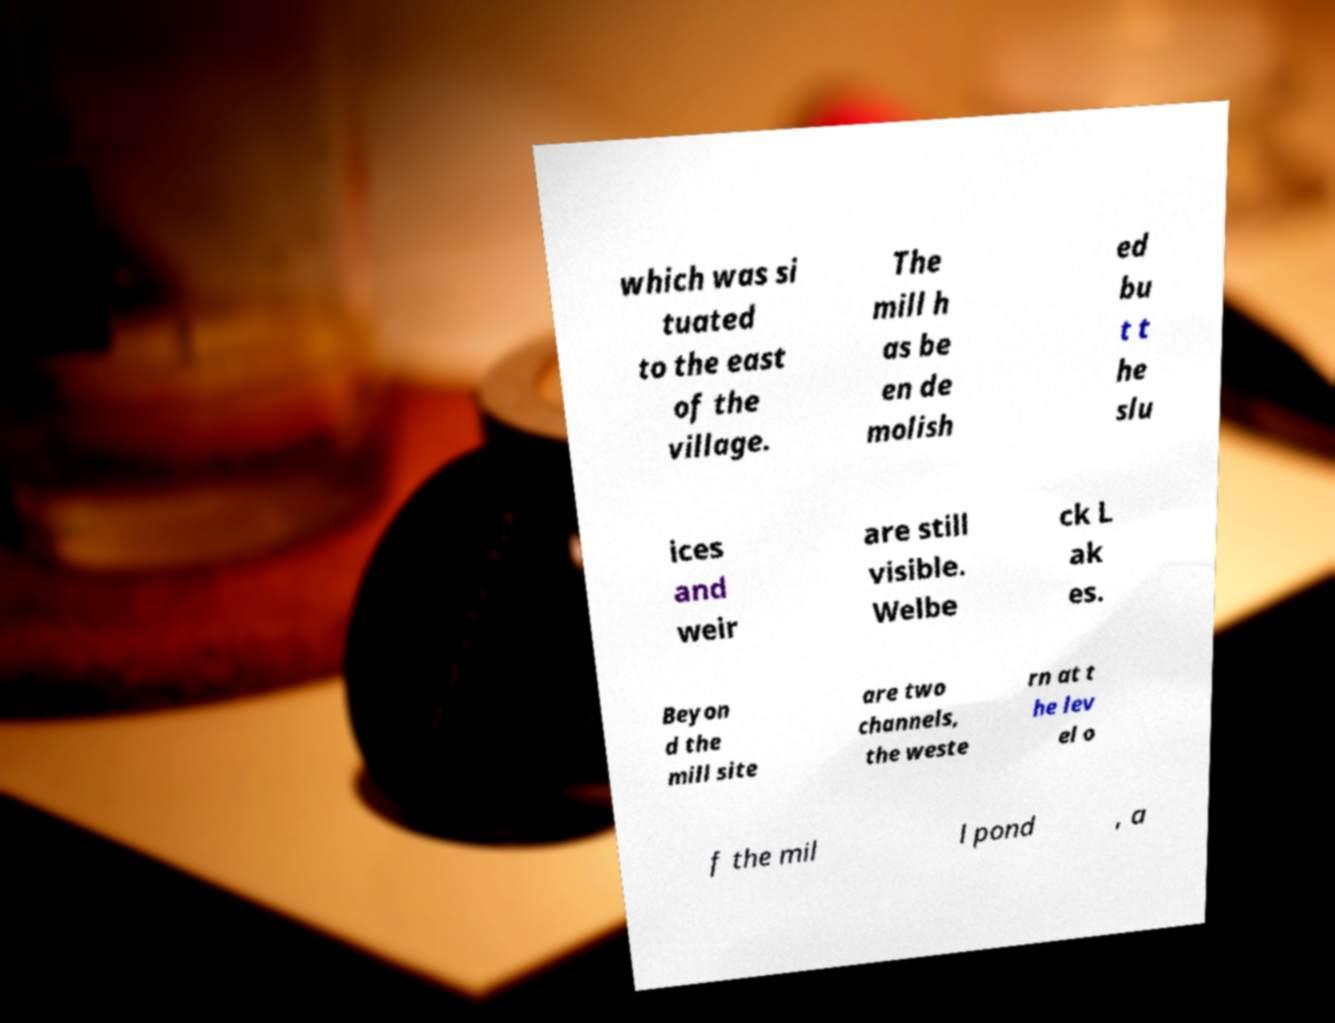Can you read and provide the text displayed in the image?This photo seems to have some interesting text. Can you extract and type it out for me? which was si tuated to the east of the village. The mill h as be en de molish ed bu t t he slu ices and weir are still visible. Welbe ck L ak es. Beyon d the mill site are two channels, the weste rn at t he lev el o f the mil l pond , a 